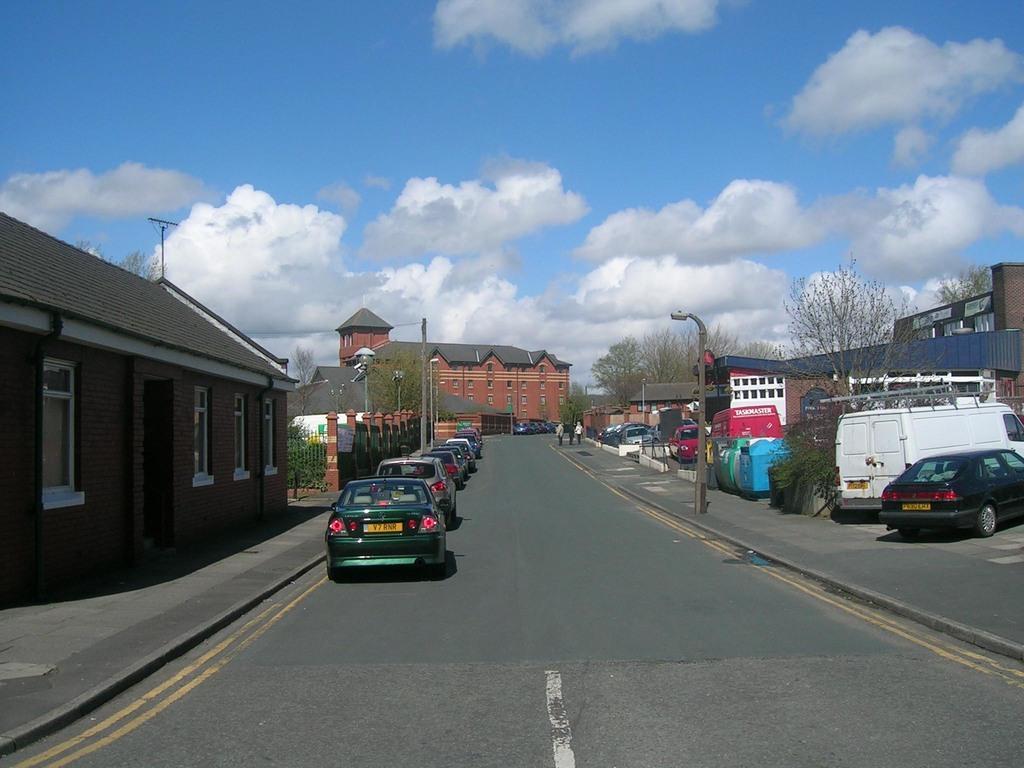In one or two sentences, can you explain what this image depicts? This image is taken outdoors. At the top of the image there is a sky with clouds. At the bottom of the image there is a road. In the middle of the image there are a few houses and buildings with walls, windows, doors and roofs. There are a few poles with street lights. There are a few trees. There is a fence and a railing. Many cars are parked on the road. Three people are walking on the sidewalk and there is a text on it. 